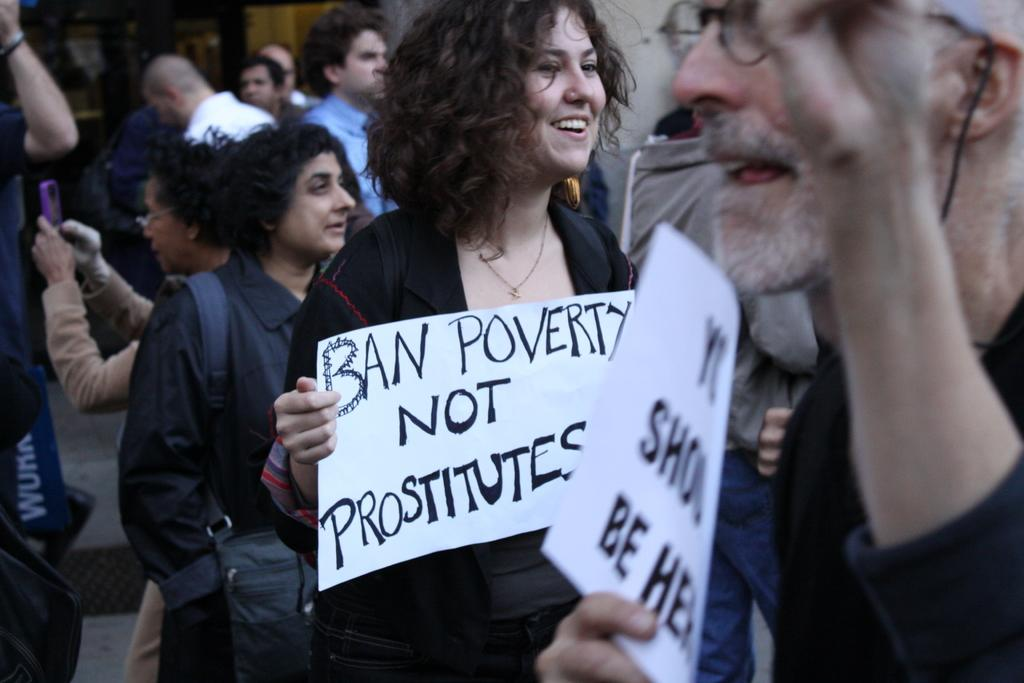Who is present in the image? There are people in the image. What are the people in the image doing? The people are protesting. Can you describe any specific actions or objects being used by the protesters? Two people are holding placards. How many bikes can be seen in the image? There are no bikes present in the image. What type of agreement is being reached by the protesters in the image? The image does not show any agreements being reached; it depicts people protesting. 